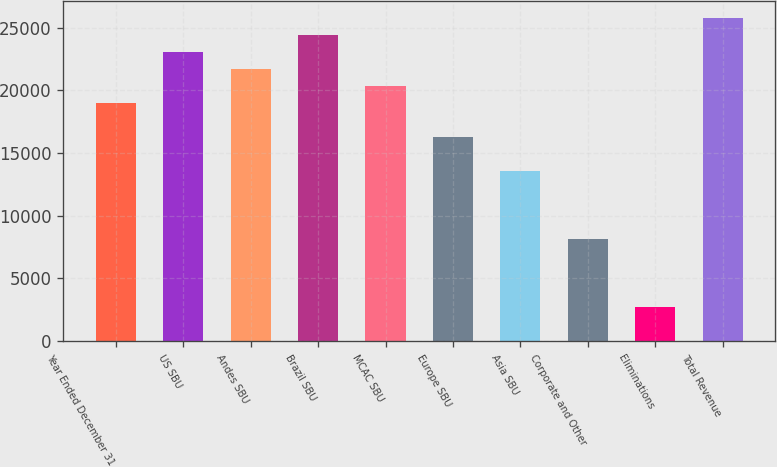Convert chart to OTSL. <chart><loc_0><loc_0><loc_500><loc_500><bar_chart><fcel>Year Ended December 31<fcel>US SBU<fcel>Andes SBU<fcel>Brazil SBU<fcel>MCAC SBU<fcel>Europe SBU<fcel>Asia SBU<fcel>Corporate and Other<fcel>Eliminations<fcel>Total Revenue<nl><fcel>19018<fcel>23092<fcel>21734<fcel>24450<fcel>20376<fcel>16302<fcel>13586<fcel>8154<fcel>2722<fcel>25808<nl></chart> 